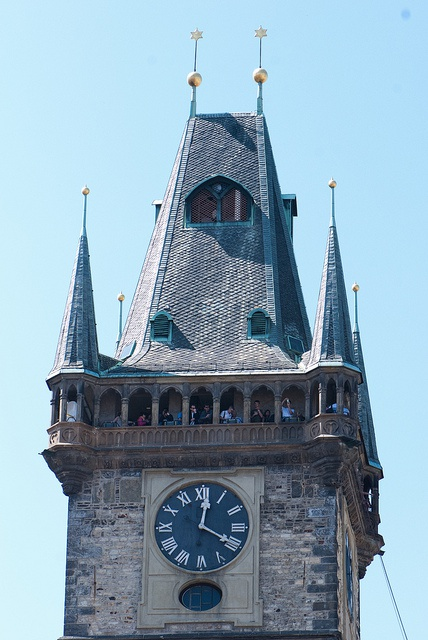Describe the objects in this image and their specific colors. I can see clock in lightblue, darkblue, gray, and black tones, people in lightblue, black, and purple tones, people in lightblue, black, gray, and navy tones, people in lightblue, black, gray, and navy tones, and people in lightblue, black, gray, and navy tones in this image. 